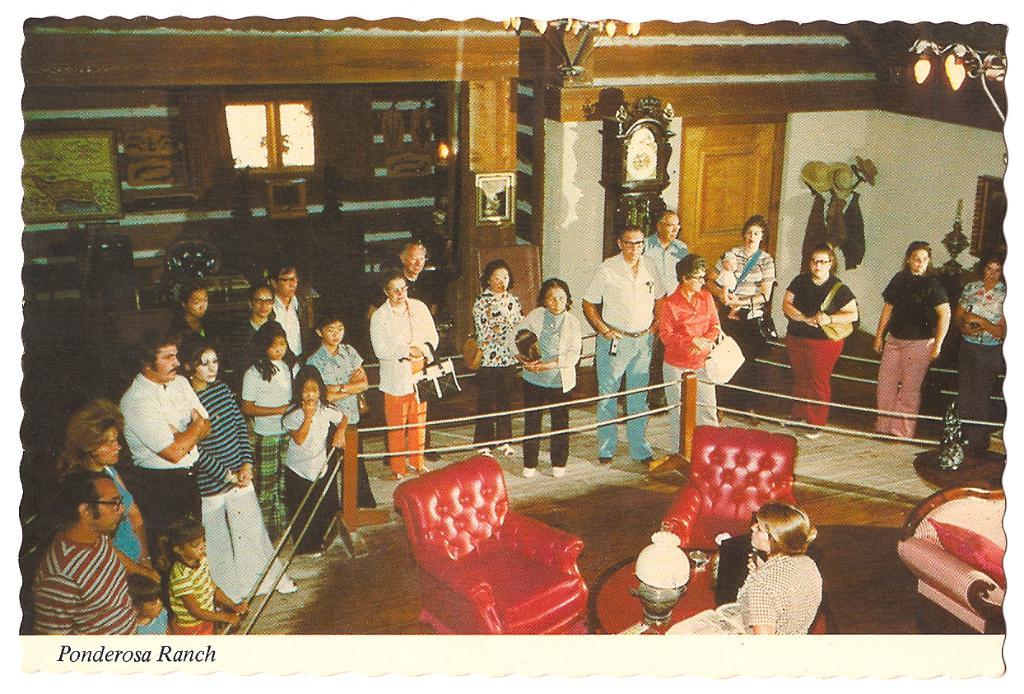Where is this photo taken?
Offer a terse response. Ponderosa ranch. 